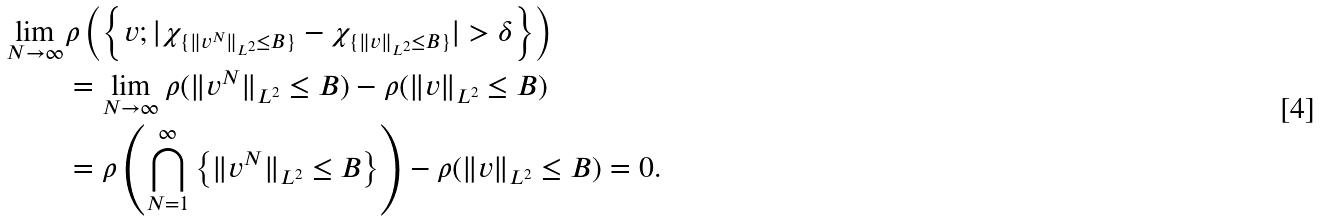Convert formula to latex. <formula><loc_0><loc_0><loc_500><loc_500>\lim _ { N \to \infty } & \rho \left ( \left \{ v ; | \chi _ { \{ \| v ^ { N } \| _ { L ^ { 2 } } \leq B \} } - \chi _ { \{ \| v \| _ { L ^ { 2 } } \leq B \} } | > \delta \right \} \right ) \\ & = \lim _ { N \to \infty } \rho ( \| v ^ { N } \| _ { L ^ { 2 } } \leq B ) - \rho ( \| v \| _ { L ^ { 2 } } \leq B ) \\ & = \rho \left ( \bigcap _ { N = 1 } ^ { \infty } \left \{ \| v ^ { N } \| _ { L ^ { 2 } } \leq B \right \} \right ) - \rho ( \| v \| _ { L ^ { 2 } } \leq B ) = 0 .</formula> 